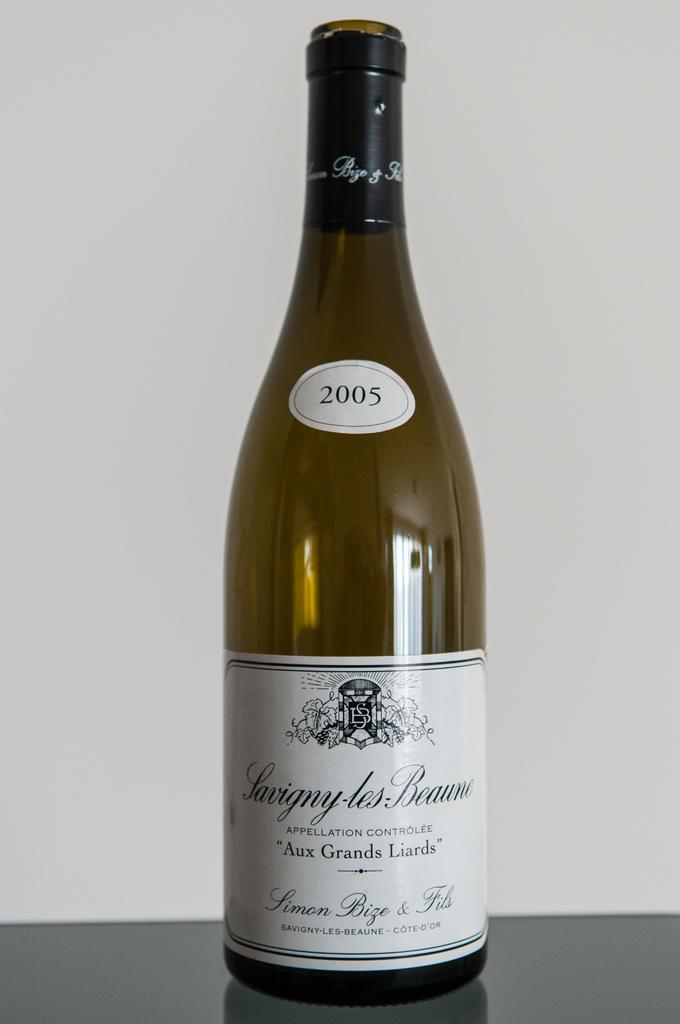What kind of wine is this?
Give a very brief answer. Savigny les beaune. What year is on the wine?
Offer a very short reply. 2005. 